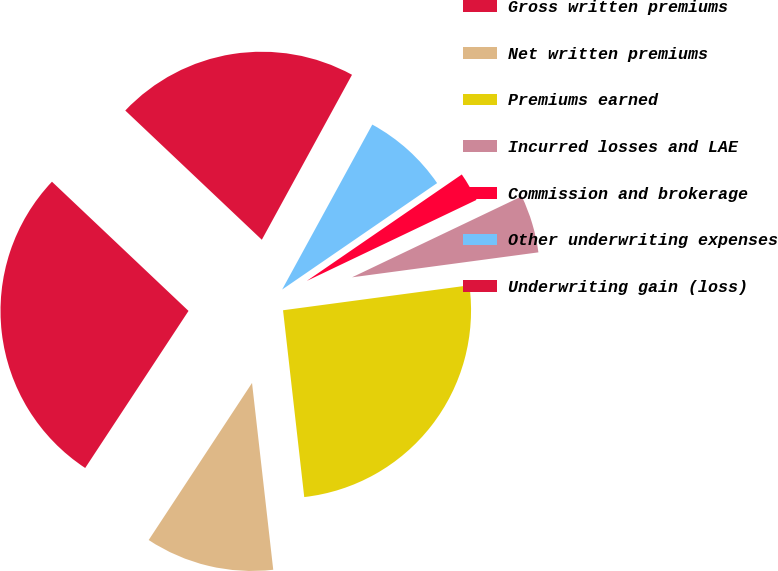Convert chart to OTSL. <chart><loc_0><loc_0><loc_500><loc_500><pie_chart><fcel>Gross written premiums<fcel>Net written premiums<fcel>Premiums earned<fcel>Incurred losses and LAE<fcel>Commission and brokerage<fcel>Other underwriting expenses<fcel>Underwriting gain (loss)<nl><fcel>27.8%<fcel>11.06%<fcel>25.32%<fcel>4.97%<fcel>2.49%<fcel>7.46%<fcel>20.9%<nl></chart> 